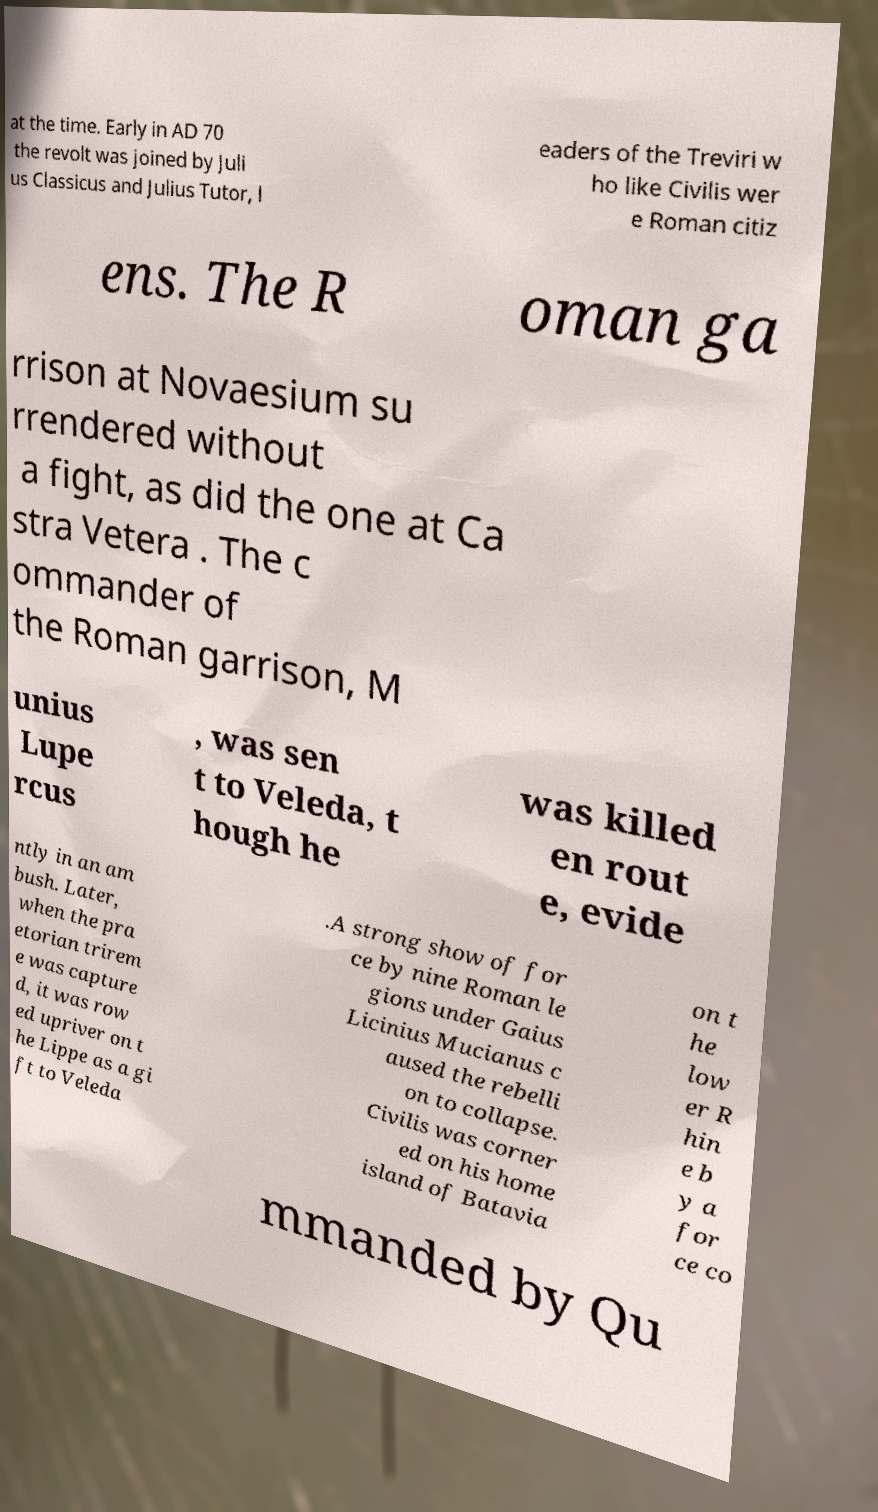There's text embedded in this image that I need extracted. Can you transcribe it verbatim? at the time. Early in AD 70 the revolt was joined by Juli us Classicus and Julius Tutor, l eaders of the Treviri w ho like Civilis wer e Roman citiz ens. The R oman ga rrison at Novaesium su rrendered without a fight, as did the one at Ca stra Vetera . The c ommander of the Roman garrison, M unius Lupe rcus , was sen t to Veleda, t hough he was killed en rout e, evide ntly in an am bush. Later, when the pra etorian trirem e was capture d, it was row ed upriver on t he Lippe as a gi ft to Veleda .A strong show of for ce by nine Roman le gions under Gaius Licinius Mucianus c aused the rebelli on to collapse. Civilis was corner ed on his home island of Batavia on t he low er R hin e b y a for ce co mmanded by Qu 